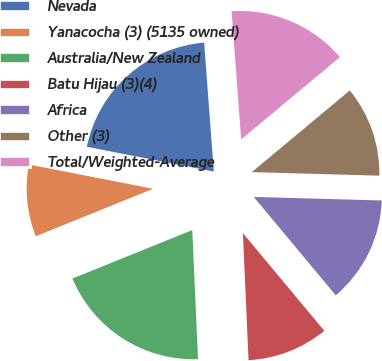Convert chart. <chart><loc_0><loc_0><loc_500><loc_500><pie_chart><fcel>Nevada<fcel>Yanacocha (3) (5135 owned)<fcel>Australia/New Zealand<fcel>Batu Hijau (3)(4)<fcel>Africa<fcel>Other (3)<fcel>Total/Weighted-Average<nl><fcel>20.74%<fcel>9.19%<fcel>19.59%<fcel>10.35%<fcel>13.5%<fcel>11.5%<fcel>15.13%<nl></chart> 